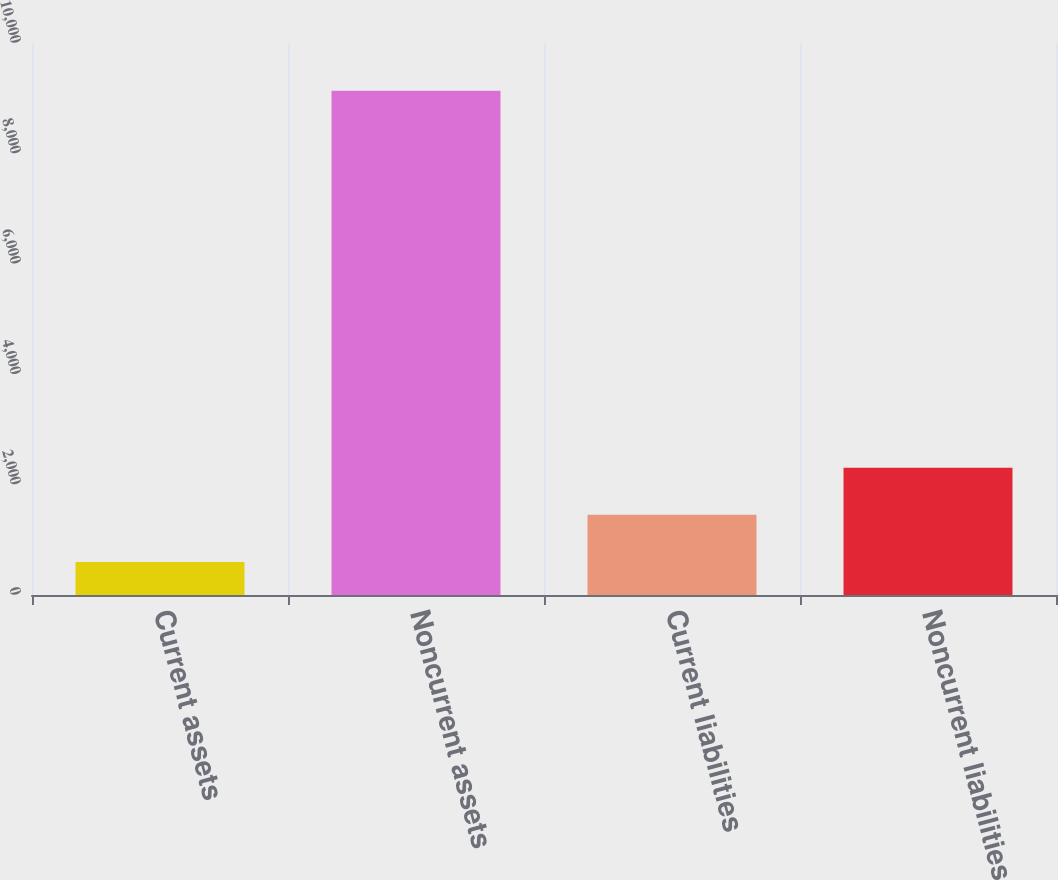Convert chart. <chart><loc_0><loc_0><loc_500><loc_500><bar_chart><fcel>Current assets<fcel>Noncurrent assets<fcel>Current liabilities<fcel>Noncurrent liabilities<nl><fcel>599<fcel>9135<fcel>1452.6<fcel>2306.2<nl></chart> 